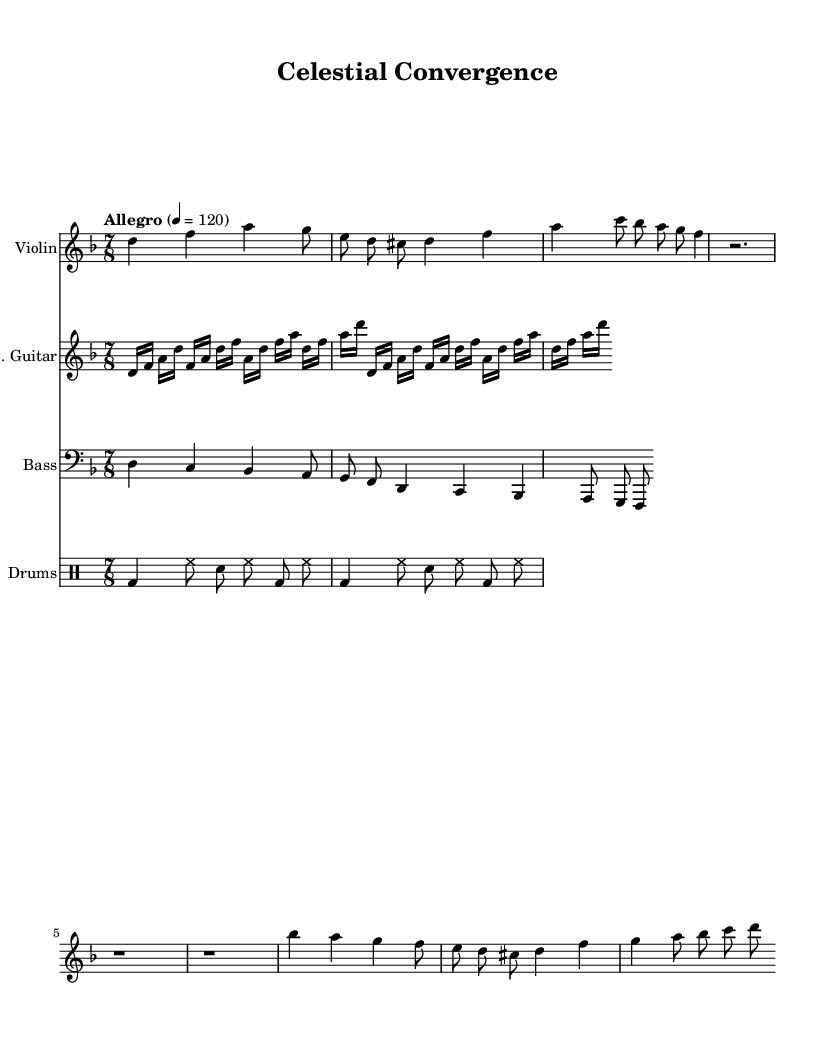What is the key signature of this music? The key signature is two flats, indicating the presence of B flat and E flat, which corresponds to D minor.
Answer: D minor What is the time signature of this piece? The time signature is 7/8, which means there are seven eighth notes in each measure.
Answer: 7/8 What is the tempo marking given? The tempo marking states "Allegro" with a metronome indication of 120 beats per minute, indicating a fast pace.
Answer: Allegro 4 = 120 How many measures does the violin part contain in the excerpt? The violin part contains three measures with distinct rhythmic values.
Answer: 3 measures What instrument plays the first melodic line? The first melodic line is played by the violin, which is indicated at the beginning of the staff.
Answer: Violin What type of guitar is featured in this composition? The sheet music specifies the use of an electric guitar type in the score, which is noted in the instrument name.
Answer: Electric guitar How many different instruments are present in the score? The score features four distinct instruments: violin, electric guitar, bass guitar, and drums.
Answer: 4 instruments 